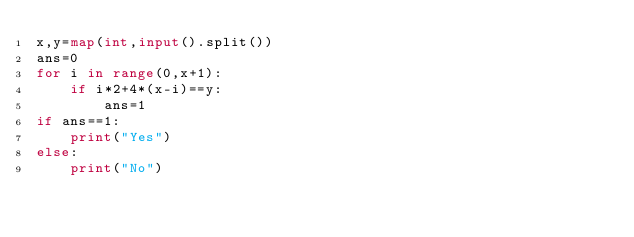Convert code to text. <code><loc_0><loc_0><loc_500><loc_500><_Python_>x,y=map(int,input().split())
ans=0
for i in range(0,x+1):
    if i*2+4*(x-i)==y:
        ans=1
if ans==1:
    print("Yes")
else:
    print("No")
    </code> 